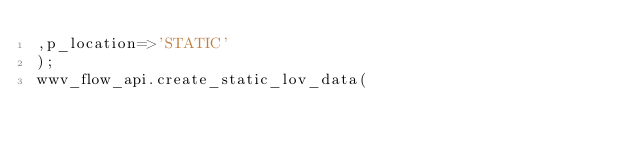<code> <loc_0><loc_0><loc_500><loc_500><_SQL_>,p_location=>'STATIC'
);
wwv_flow_api.create_static_lov_data(</code> 